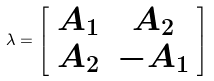<formula> <loc_0><loc_0><loc_500><loc_500>\lambda = \left [ \begin{array} { c c } A _ { 1 } & A _ { 2 } \\ A _ { 2 } & - A _ { 1 } \end{array} \right ]</formula> 